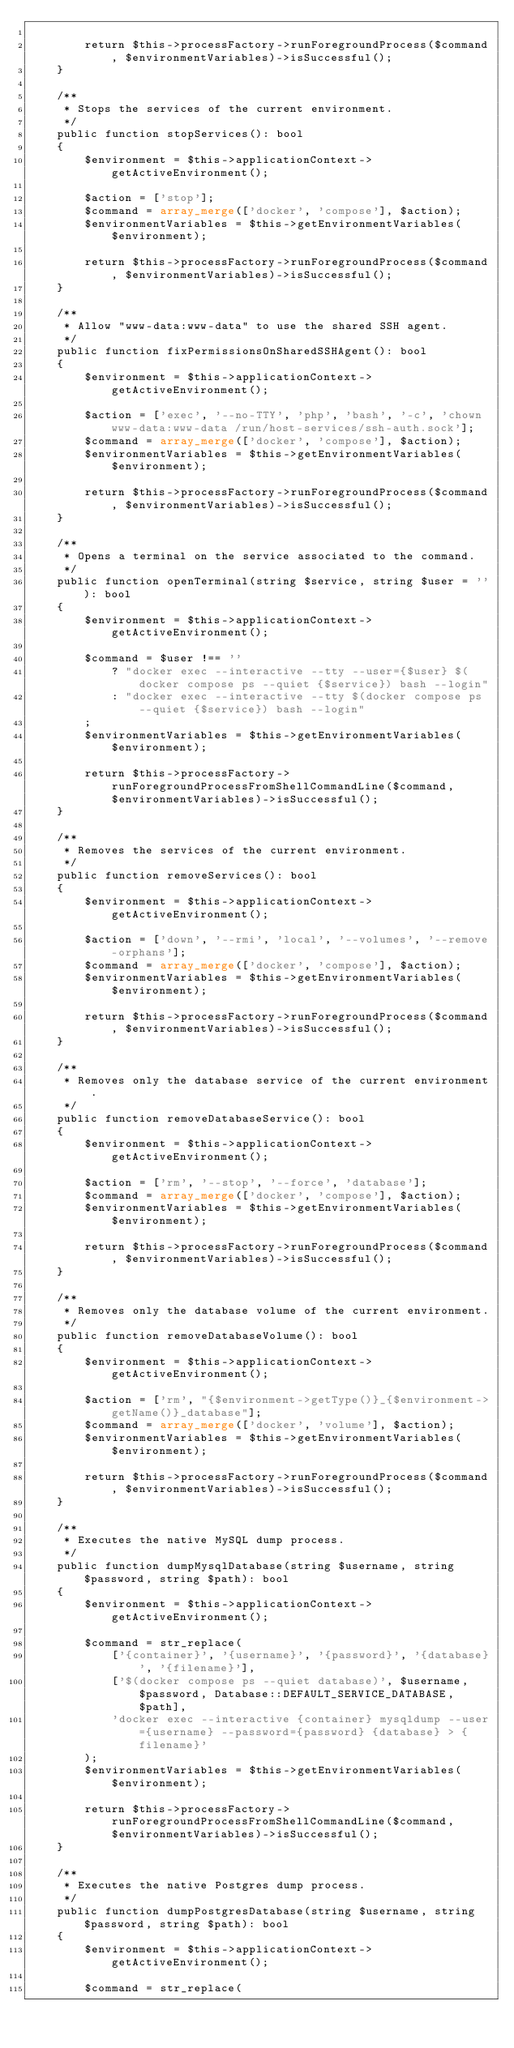<code> <loc_0><loc_0><loc_500><loc_500><_PHP_>
        return $this->processFactory->runForegroundProcess($command, $environmentVariables)->isSuccessful();
    }

    /**
     * Stops the services of the current environment.
     */
    public function stopServices(): bool
    {
        $environment = $this->applicationContext->getActiveEnvironment();

        $action = ['stop'];
        $command = array_merge(['docker', 'compose'], $action);
        $environmentVariables = $this->getEnvironmentVariables($environment);

        return $this->processFactory->runForegroundProcess($command, $environmentVariables)->isSuccessful();
    }

    /**
     * Allow "www-data:www-data" to use the shared SSH agent.
     */
    public function fixPermissionsOnSharedSSHAgent(): bool
    {
        $environment = $this->applicationContext->getActiveEnvironment();

        $action = ['exec', '--no-TTY', 'php', 'bash', '-c', 'chown www-data:www-data /run/host-services/ssh-auth.sock'];
        $command = array_merge(['docker', 'compose'], $action);
        $environmentVariables = $this->getEnvironmentVariables($environment);

        return $this->processFactory->runForegroundProcess($command, $environmentVariables)->isSuccessful();
    }

    /**
     * Opens a terminal on the service associated to the command.
     */
    public function openTerminal(string $service, string $user = ''): bool
    {
        $environment = $this->applicationContext->getActiveEnvironment();

        $command = $user !== ''
            ? "docker exec --interactive --tty --user={$user} $(docker compose ps --quiet {$service}) bash --login"
            : "docker exec --interactive --tty $(docker compose ps --quiet {$service}) bash --login"
        ;
        $environmentVariables = $this->getEnvironmentVariables($environment);

        return $this->processFactory->runForegroundProcessFromShellCommandLine($command, $environmentVariables)->isSuccessful();
    }

    /**
     * Removes the services of the current environment.
     */
    public function removeServices(): bool
    {
        $environment = $this->applicationContext->getActiveEnvironment();

        $action = ['down', '--rmi', 'local', '--volumes', '--remove-orphans'];
        $command = array_merge(['docker', 'compose'], $action);
        $environmentVariables = $this->getEnvironmentVariables($environment);

        return $this->processFactory->runForegroundProcess($command, $environmentVariables)->isSuccessful();
    }

    /**
     * Removes only the database service of the current environment.
     */
    public function removeDatabaseService(): bool
    {
        $environment = $this->applicationContext->getActiveEnvironment();

        $action = ['rm', '--stop', '--force', 'database'];
        $command = array_merge(['docker', 'compose'], $action);
        $environmentVariables = $this->getEnvironmentVariables($environment);

        return $this->processFactory->runForegroundProcess($command, $environmentVariables)->isSuccessful();
    }

    /**
     * Removes only the database volume of the current environment.
     */
    public function removeDatabaseVolume(): bool
    {
        $environment = $this->applicationContext->getActiveEnvironment();

        $action = ['rm', "{$environment->getType()}_{$environment->getName()}_database"];
        $command = array_merge(['docker', 'volume'], $action);
        $environmentVariables = $this->getEnvironmentVariables($environment);

        return $this->processFactory->runForegroundProcess($command, $environmentVariables)->isSuccessful();
    }

    /**
     * Executes the native MySQL dump process.
     */
    public function dumpMysqlDatabase(string $username, string $password, string $path): bool
    {
        $environment = $this->applicationContext->getActiveEnvironment();

        $command = str_replace(
            ['{container}', '{username}', '{password}', '{database}', '{filename}'],
            ['$(docker compose ps --quiet database)', $username, $password, Database::DEFAULT_SERVICE_DATABASE, $path],
            'docker exec --interactive {container} mysqldump --user={username} --password={password} {database} > {filename}'
        );
        $environmentVariables = $this->getEnvironmentVariables($environment);

        return $this->processFactory->runForegroundProcessFromShellCommandLine($command, $environmentVariables)->isSuccessful();
    }

    /**
     * Executes the native Postgres dump process.
     */
    public function dumpPostgresDatabase(string $username, string $password, string $path): bool
    {
        $environment = $this->applicationContext->getActiveEnvironment();

        $command = str_replace(</code> 